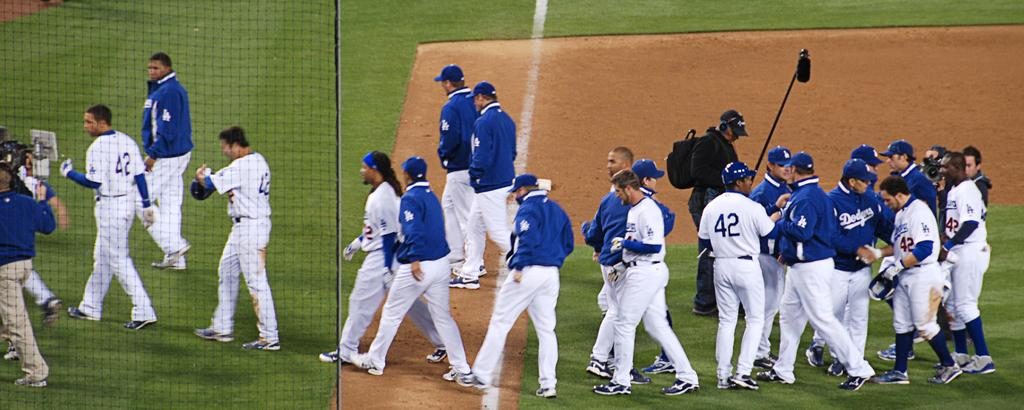Provide a one-sentence caption for the provided image. Members of a the Dodgers basbeall team mill about as an audio technical holds a microphone above them. 